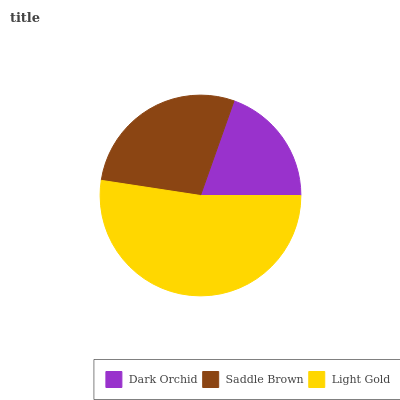Is Dark Orchid the minimum?
Answer yes or no. Yes. Is Light Gold the maximum?
Answer yes or no. Yes. Is Saddle Brown the minimum?
Answer yes or no. No. Is Saddle Brown the maximum?
Answer yes or no. No. Is Saddle Brown greater than Dark Orchid?
Answer yes or no. Yes. Is Dark Orchid less than Saddle Brown?
Answer yes or no. Yes. Is Dark Orchid greater than Saddle Brown?
Answer yes or no. No. Is Saddle Brown less than Dark Orchid?
Answer yes or no. No. Is Saddle Brown the high median?
Answer yes or no. Yes. Is Saddle Brown the low median?
Answer yes or no. Yes. Is Light Gold the high median?
Answer yes or no. No. Is Dark Orchid the low median?
Answer yes or no. No. 